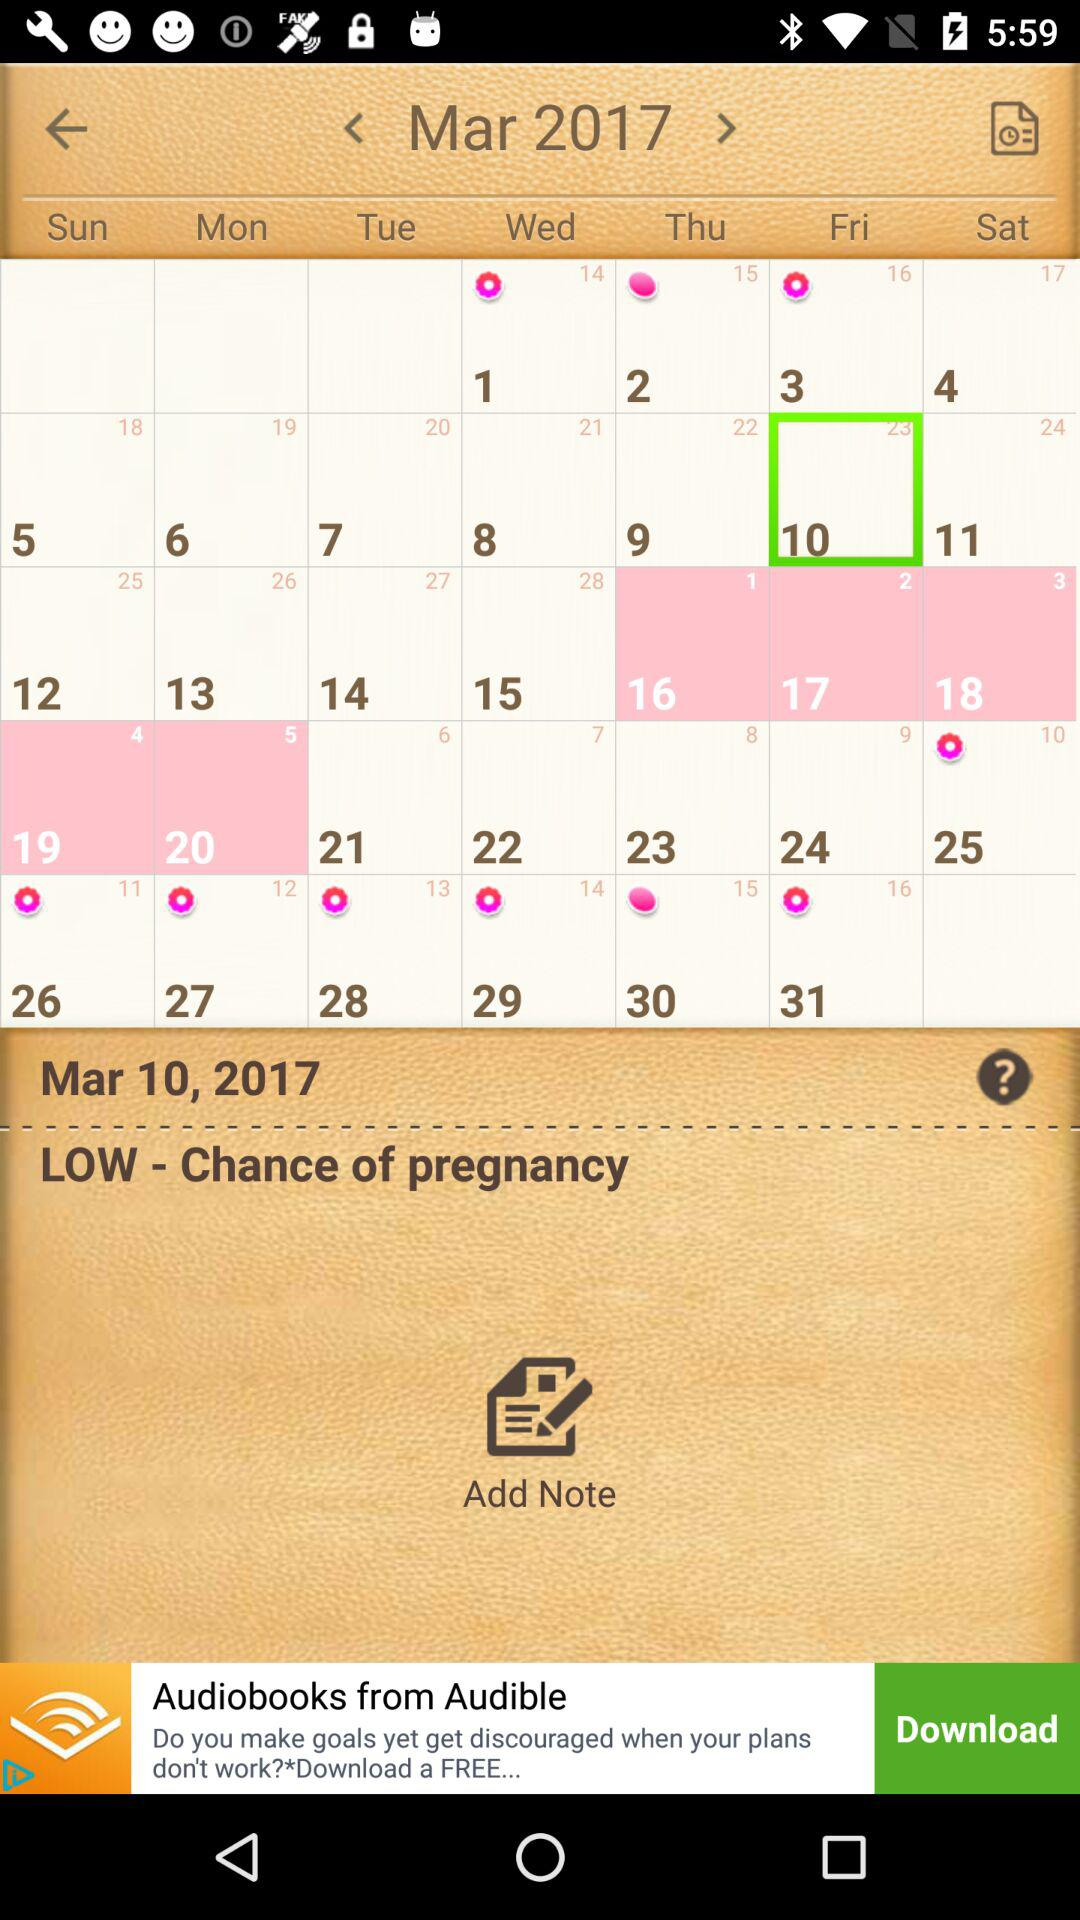When is the chance of pregnancy low? The chance of pregnancy is low on March 10, 2017. 